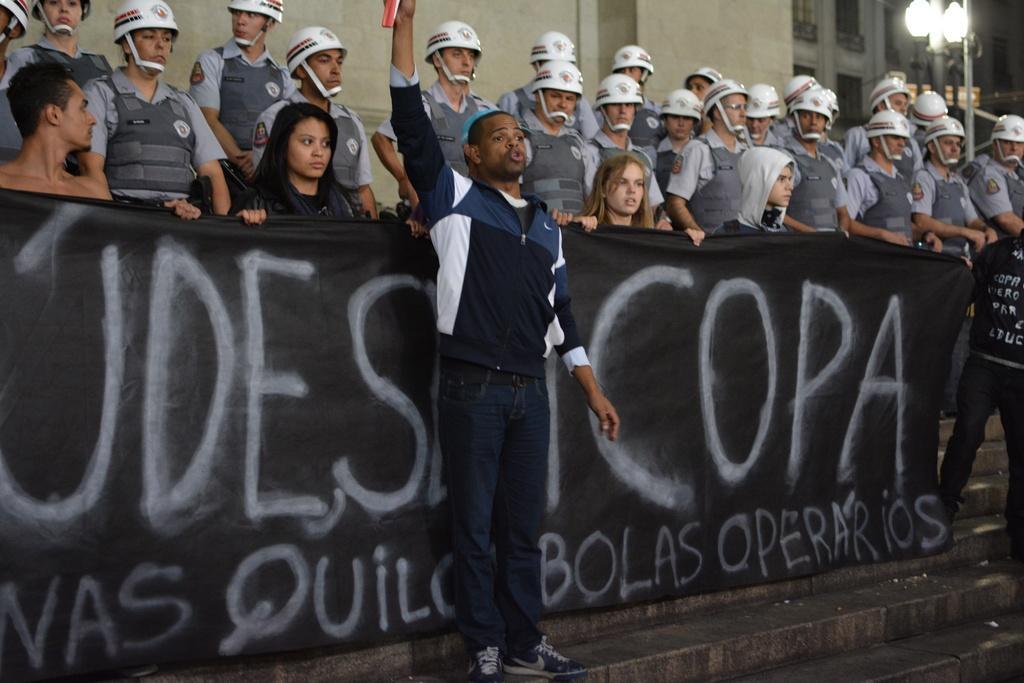Can you describe this image briefly? In this picture, this man is standing and raising his hand. Backside of this man there are a group of people. These people are holding a banner. Background we can see a light pole and building.  